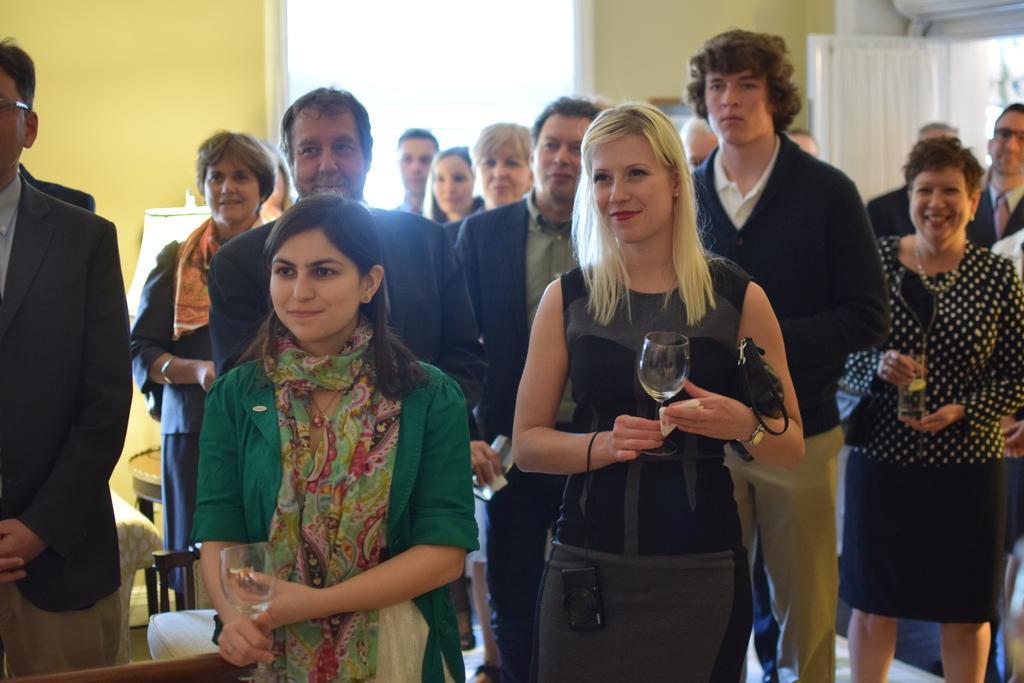Describe this image in one or two sentences. In this image I can see a group of people holding the wine glasses in the middle, on the left side I can see a light. 